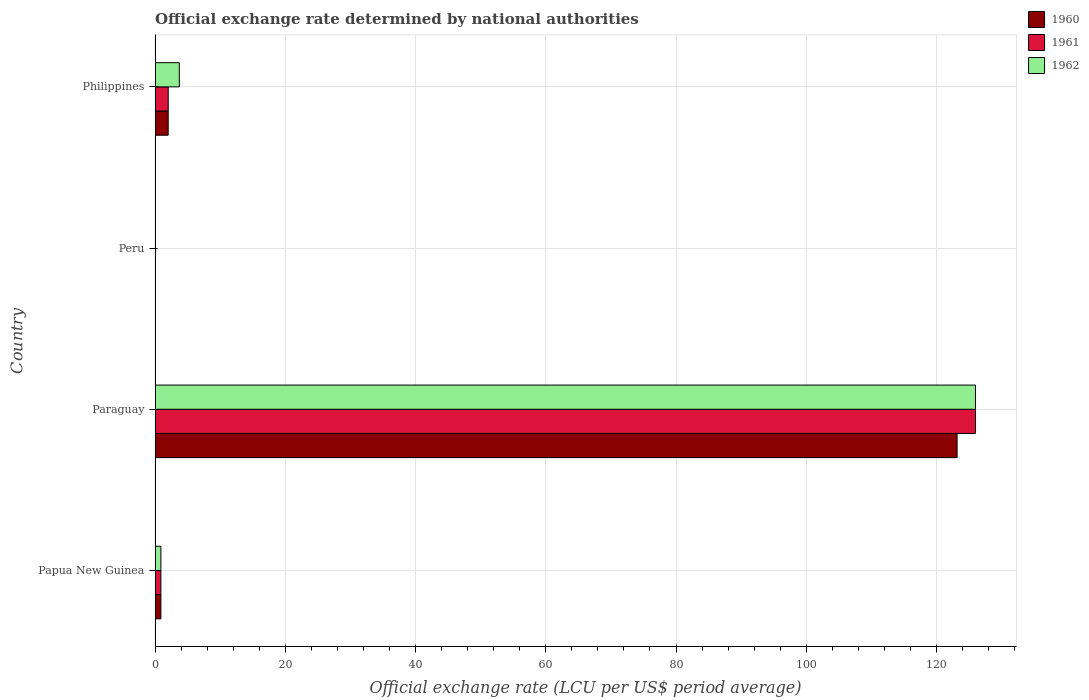How many different coloured bars are there?
Your answer should be compact. 3. How many groups of bars are there?
Your answer should be very brief. 4. Are the number of bars on each tick of the Y-axis equal?
Offer a terse response. Yes. What is the label of the 3rd group of bars from the top?
Give a very brief answer. Paraguay. In how many cases, is the number of bars for a given country not equal to the number of legend labels?
Provide a short and direct response. 0. What is the official exchange rate in 1962 in Papua New Guinea?
Keep it short and to the point. 0.89. Across all countries, what is the maximum official exchange rate in 1962?
Your response must be concise. 126. Across all countries, what is the minimum official exchange rate in 1960?
Ensure brevity in your answer.  2.729916666591669e-8. In which country was the official exchange rate in 1961 maximum?
Make the answer very short. Paraguay. In which country was the official exchange rate in 1962 minimum?
Your answer should be very brief. Peru. What is the total official exchange rate in 1961 in the graph?
Your answer should be very brief. 128.91. What is the difference between the official exchange rate in 1961 in Peru and that in Philippines?
Provide a short and direct response. -2.02. What is the difference between the official exchange rate in 1962 in Peru and the official exchange rate in 1961 in Philippines?
Provide a short and direct response. -2.02. What is the average official exchange rate in 1961 per country?
Provide a succinct answer. 32.23. What is the difference between the official exchange rate in 1960 and official exchange rate in 1961 in Philippines?
Your answer should be compact. -0. In how many countries, is the official exchange rate in 1961 greater than 28 LCU?
Your answer should be very brief. 1. What is the ratio of the official exchange rate in 1960 in Paraguay to that in Peru?
Your answer should be compact. 4.51e+09. Is the official exchange rate in 1962 in Papua New Guinea less than that in Paraguay?
Your answer should be compact. Yes. Is the difference between the official exchange rate in 1960 in Peru and Philippines greater than the difference between the official exchange rate in 1961 in Peru and Philippines?
Provide a short and direct response. Yes. What is the difference between the highest and the second highest official exchange rate in 1961?
Provide a short and direct response. 123.98. What is the difference between the highest and the lowest official exchange rate in 1962?
Make the answer very short. 126. In how many countries, is the official exchange rate in 1960 greater than the average official exchange rate in 1960 taken over all countries?
Keep it short and to the point. 1. Is the sum of the official exchange rate in 1960 in Paraguay and Peru greater than the maximum official exchange rate in 1962 across all countries?
Provide a short and direct response. No. What does the 3rd bar from the bottom in Peru represents?
Your response must be concise. 1962. Are all the bars in the graph horizontal?
Keep it short and to the point. Yes. How many countries are there in the graph?
Make the answer very short. 4. What is the difference between two consecutive major ticks on the X-axis?
Make the answer very short. 20. Are the values on the major ticks of X-axis written in scientific E-notation?
Your response must be concise. No. Does the graph contain any zero values?
Provide a succinct answer. No. Does the graph contain grids?
Give a very brief answer. Yes. How many legend labels are there?
Give a very brief answer. 3. How are the legend labels stacked?
Your response must be concise. Vertical. What is the title of the graph?
Give a very brief answer. Official exchange rate determined by national authorities. Does "1993" appear as one of the legend labels in the graph?
Keep it short and to the point. No. What is the label or title of the X-axis?
Keep it short and to the point. Official exchange rate (LCU per US$ period average). What is the Official exchange rate (LCU per US$ period average) of 1960 in Papua New Guinea?
Your answer should be very brief. 0.89. What is the Official exchange rate (LCU per US$ period average) of 1961 in Papua New Guinea?
Keep it short and to the point. 0.89. What is the Official exchange rate (LCU per US$ period average) of 1962 in Papua New Guinea?
Keep it short and to the point. 0.89. What is the Official exchange rate (LCU per US$ period average) in 1960 in Paraguay?
Ensure brevity in your answer.  123.17. What is the Official exchange rate (LCU per US$ period average) of 1961 in Paraguay?
Offer a terse response. 126. What is the Official exchange rate (LCU per US$ period average) of 1962 in Paraguay?
Offer a terse response. 126. What is the Official exchange rate (LCU per US$ period average) of 1960 in Peru?
Give a very brief answer. 2.729916666591669e-8. What is the Official exchange rate (LCU per US$ period average) in 1961 in Peru?
Offer a terse response. 2.681666666575e-8. What is the Official exchange rate (LCU per US$ period average) in 1962 in Peru?
Offer a terse response. 2.6819999999e-8. What is the Official exchange rate (LCU per US$ period average) in 1960 in Philippines?
Keep it short and to the point. 2.01. What is the Official exchange rate (LCU per US$ period average) of 1961 in Philippines?
Offer a terse response. 2.02. What is the Official exchange rate (LCU per US$ period average) in 1962 in Philippines?
Keep it short and to the point. 3.73. Across all countries, what is the maximum Official exchange rate (LCU per US$ period average) in 1960?
Your response must be concise. 123.17. Across all countries, what is the maximum Official exchange rate (LCU per US$ period average) of 1961?
Your answer should be compact. 126. Across all countries, what is the maximum Official exchange rate (LCU per US$ period average) of 1962?
Your answer should be compact. 126. Across all countries, what is the minimum Official exchange rate (LCU per US$ period average) of 1960?
Ensure brevity in your answer.  2.729916666591669e-8. Across all countries, what is the minimum Official exchange rate (LCU per US$ period average) of 1961?
Ensure brevity in your answer.  2.681666666575e-8. Across all countries, what is the minimum Official exchange rate (LCU per US$ period average) of 1962?
Make the answer very short. 2.6819999999e-8. What is the total Official exchange rate (LCU per US$ period average) of 1960 in the graph?
Offer a terse response. 126.07. What is the total Official exchange rate (LCU per US$ period average) of 1961 in the graph?
Your answer should be very brief. 128.91. What is the total Official exchange rate (LCU per US$ period average) of 1962 in the graph?
Offer a terse response. 130.62. What is the difference between the Official exchange rate (LCU per US$ period average) in 1960 in Papua New Guinea and that in Paraguay?
Keep it short and to the point. -122.27. What is the difference between the Official exchange rate (LCU per US$ period average) in 1961 in Papua New Guinea and that in Paraguay?
Your answer should be very brief. -125.11. What is the difference between the Official exchange rate (LCU per US$ period average) of 1962 in Papua New Guinea and that in Paraguay?
Offer a very short reply. -125.11. What is the difference between the Official exchange rate (LCU per US$ period average) in 1960 in Papua New Guinea and that in Peru?
Offer a very short reply. 0.89. What is the difference between the Official exchange rate (LCU per US$ period average) in 1961 in Papua New Guinea and that in Peru?
Your answer should be very brief. 0.89. What is the difference between the Official exchange rate (LCU per US$ period average) in 1962 in Papua New Guinea and that in Peru?
Ensure brevity in your answer.  0.89. What is the difference between the Official exchange rate (LCU per US$ period average) of 1960 in Papua New Guinea and that in Philippines?
Give a very brief answer. -1.12. What is the difference between the Official exchange rate (LCU per US$ period average) of 1961 in Papua New Guinea and that in Philippines?
Offer a terse response. -1.13. What is the difference between the Official exchange rate (LCU per US$ period average) in 1962 in Papua New Guinea and that in Philippines?
Your response must be concise. -2.83. What is the difference between the Official exchange rate (LCU per US$ period average) in 1960 in Paraguay and that in Peru?
Make the answer very short. 123.17. What is the difference between the Official exchange rate (LCU per US$ period average) of 1961 in Paraguay and that in Peru?
Your response must be concise. 126. What is the difference between the Official exchange rate (LCU per US$ period average) of 1962 in Paraguay and that in Peru?
Provide a short and direct response. 126. What is the difference between the Official exchange rate (LCU per US$ period average) of 1960 in Paraguay and that in Philippines?
Your answer should be very brief. 121.15. What is the difference between the Official exchange rate (LCU per US$ period average) in 1961 in Paraguay and that in Philippines?
Your answer should be compact. 123.98. What is the difference between the Official exchange rate (LCU per US$ period average) of 1962 in Paraguay and that in Philippines?
Ensure brevity in your answer.  122.27. What is the difference between the Official exchange rate (LCU per US$ period average) in 1960 in Peru and that in Philippines?
Keep it short and to the point. -2.02. What is the difference between the Official exchange rate (LCU per US$ period average) of 1961 in Peru and that in Philippines?
Provide a short and direct response. -2.02. What is the difference between the Official exchange rate (LCU per US$ period average) in 1962 in Peru and that in Philippines?
Give a very brief answer. -3.73. What is the difference between the Official exchange rate (LCU per US$ period average) in 1960 in Papua New Guinea and the Official exchange rate (LCU per US$ period average) in 1961 in Paraguay?
Keep it short and to the point. -125.11. What is the difference between the Official exchange rate (LCU per US$ period average) in 1960 in Papua New Guinea and the Official exchange rate (LCU per US$ period average) in 1962 in Paraguay?
Your response must be concise. -125.11. What is the difference between the Official exchange rate (LCU per US$ period average) in 1961 in Papua New Guinea and the Official exchange rate (LCU per US$ period average) in 1962 in Paraguay?
Your response must be concise. -125.11. What is the difference between the Official exchange rate (LCU per US$ period average) of 1960 in Papua New Guinea and the Official exchange rate (LCU per US$ period average) of 1961 in Peru?
Keep it short and to the point. 0.89. What is the difference between the Official exchange rate (LCU per US$ period average) of 1960 in Papua New Guinea and the Official exchange rate (LCU per US$ period average) of 1962 in Peru?
Your response must be concise. 0.89. What is the difference between the Official exchange rate (LCU per US$ period average) in 1961 in Papua New Guinea and the Official exchange rate (LCU per US$ period average) in 1962 in Peru?
Make the answer very short. 0.89. What is the difference between the Official exchange rate (LCU per US$ period average) of 1960 in Papua New Guinea and the Official exchange rate (LCU per US$ period average) of 1961 in Philippines?
Ensure brevity in your answer.  -1.13. What is the difference between the Official exchange rate (LCU per US$ period average) of 1960 in Papua New Guinea and the Official exchange rate (LCU per US$ period average) of 1962 in Philippines?
Make the answer very short. -2.83. What is the difference between the Official exchange rate (LCU per US$ period average) in 1961 in Papua New Guinea and the Official exchange rate (LCU per US$ period average) in 1962 in Philippines?
Your answer should be very brief. -2.83. What is the difference between the Official exchange rate (LCU per US$ period average) in 1960 in Paraguay and the Official exchange rate (LCU per US$ period average) in 1961 in Peru?
Give a very brief answer. 123.17. What is the difference between the Official exchange rate (LCU per US$ period average) of 1960 in Paraguay and the Official exchange rate (LCU per US$ period average) of 1962 in Peru?
Provide a short and direct response. 123.17. What is the difference between the Official exchange rate (LCU per US$ period average) of 1961 in Paraguay and the Official exchange rate (LCU per US$ period average) of 1962 in Peru?
Your answer should be compact. 126. What is the difference between the Official exchange rate (LCU per US$ period average) in 1960 in Paraguay and the Official exchange rate (LCU per US$ period average) in 1961 in Philippines?
Provide a succinct answer. 121.15. What is the difference between the Official exchange rate (LCU per US$ period average) of 1960 in Paraguay and the Official exchange rate (LCU per US$ period average) of 1962 in Philippines?
Give a very brief answer. 119.44. What is the difference between the Official exchange rate (LCU per US$ period average) in 1961 in Paraguay and the Official exchange rate (LCU per US$ period average) in 1962 in Philippines?
Your answer should be very brief. 122.27. What is the difference between the Official exchange rate (LCU per US$ period average) in 1960 in Peru and the Official exchange rate (LCU per US$ period average) in 1961 in Philippines?
Your answer should be compact. -2.02. What is the difference between the Official exchange rate (LCU per US$ period average) of 1960 in Peru and the Official exchange rate (LCU per US$ period average) of 1962 in Philippines?
Your answer should be very brief. -3.73. What is the difference between the Official exchange rate (LCU per US$ period average) in 1961 in Peru and the Official exchange rate (LCU per US$ period average) in 1962 in Philippines?
Keep it short and to the point. -3.73. What is the average Official exchange rate (LCU per US$ period average) in 1960 per country?
Make the answer very short. 31.52. What is the average Official exchange rate (LCU per US$ period average) in 1961 per country?
Offer a terse response. 32.23. What is the average Official exchange rate (LCU per US$ period average) in 1962 per country?
Provide a short and direct response. 32.66. What is the difference between the Official exchange rate (LCU per US$ period average) in 1961 and Official exchange rate (LCU per US$ period average) in 1962 in Papua New Guinea?
Give a very brief answer. 0. What is the difference between the Official exchange rate (LCU per US$ period average) of 1960 and Official exchange rate (LCU per US$ period average) of 1961 in Paraguay?
Make the answer very short. -2.83. What is the difference between the Official exchange rate (LCU per US$ period average) in 1960 and Official exchange rate (LCU per US$ period average) in 1962 in Paraguay?
Give a very brief answer. -2.83. What is the difference between the Official exchange rate (LCU per US$ period average) of 1961 and Official exchange rate (LCU per US$ period average) of 1962 in Paraguay?
Your response must be concise. 0. What is the difference between the Official exchange rate (LCU per US$ period average) of 1960 and Official exchange rate (LCU per US$ period average) of 1961 in Peru?
Provide a succinct answer. 0. What is the difference between the Official exchange rate (LCU per US$ period average) of 1961 and Official exchange rate (LCU per US$ period average) of 1962 in Peru?
Provide a short and direct response. -0. What is the difference between the Official exchange rate (LCU per US$ period average) in 1960 and Official exchange rate (LCU per US$ period average) in 1961 in Philippines?
Your answer should be very brief. -0.01. What is the difference between the Official exchange rate (LCU per US$ period average) of 1960 and Official exchange rate (LCU per US$ period average) of 1962 in Philippines?
Provide a short and direct response. -1.71. What is the difference between the Official exchange rate (LCU per US$ period average) in 1961 and Official exchange rate (LCU per US$ period average) in 1962 in Philippines?
Provide a short and direct response. -1.71. What is the ratio of the Official exchange rate (LCU per US$ period average) in 1960 in Papua New Guinea to that in Paraguay?
Your response must be concise. 0.01. What is the ratio of the Official exchange rate (LCU per US$ period average) of 1961 in Papua New Guinea to that in Paraguay?
Your answer should be very brief. 0.01. What is the ratio of the Official exchange rate (LCU per US$ period average) in 1962 in Papua New Guinea to that in Paraguay?
Offer a terse response. 0.01. What is the ratio of the Official exchange rate (LCU per US$ period average) in 1960 in Papua New Guinea to that in Peru?
Your answer should be compact. 3.27e+07. What is the ratio of the Official exchange rate (LCU per US$ period average) of 1961 in Papua New Guinea to that in Peru?
Offer a very short reply. 3.33e+07. What is the ratio of the Official exchange rate (LCU per US$ period average) of 1962 in Papua New Guinea to that in Peru?
Keep it short and to the point. 3.33e+07. What is the ratio of the Official exchange rate (LCU per US$ period average) of 1960 in Papua New Guinea to that in Philippines?
Provide a short and direct response. 0.44. What is the ratio of the Official exchange rate (LCU per US$ period average) in 1961 in Papua New Guinea to that in Philippines?
Give a very brief answer. 0.44. What is the ratio of the Official exchange rate (LCU per US$ period average) of 1962 in Papua New Guinea to that in Philippines?
Keep it short and to the point. 0.24. What is the ratio of the Official exchange rate (LCU per US$ period average) in 1960 in Paraguay to that in Peru?
Provide a succinct answer. 4.51e+09. What is the ratio of the Official exchange rate (LCU per US$ period average) of 1961 in Paraguay to that in Peru?
Your answer should be very brief. 4.70e+09. What is the ratio of the Official exchange rate (LCU per US$ period average) of 1962 in Paraguay to that in Peru?
Offer a terse response. 4.70e+09. What is the ratio of the Official exchange rate (LCU per US$ period average) of 1960 in Paraguay to that in Philippines?
Your answer should be compact. 61.12. What is the ratio of the Official exchange rate (LCU per US$ period average) in 1961 in Paraguay to that in Philippines?
Your response must be concise. 62.38. What is the ratio of the Official exchange rate (LCU per US$ period average) in 1962 in Paraguay to that in Philippines?
Your answer should be compact. 33.8. What is the ratio of the Official exchange rate (LCU per US$ period average) in 1961 in Peru to that in Philippines?
Make the answer very short. 0. What is the difference between the highest and the second highest Official exchange rate (LCU per US$ period average) in 1960?
Provide a succinct answer. 121.15. What is the difference between the highest and the second highest Official exchange rate (LCU per US$ period average) of 1961?
Provide a short and direct response. 123.98. What is the difference between the highest and the second highest Official exchange rate (LCU per US$ period average) in 1962?
Make the answer very short. 122.27. What is the difference between the highest and the lowest Official exchange rate (LCU per US$ period average) of 1960?
Keep it short and to the point. 123.17. What is the difference between the highest and the lowest Official exchange rate (LCU per US$ period average) in 1961?
Offer a terse response. 126. What is the difference between the highest and the lowest Official exchange rate (LCU per US$ period average) of 1962?
Your answer should be very brief. 126. 